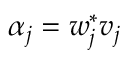Convert formula to latex. <formula><loc_0><loc_0><loc_500><loc_500>\alpha _ { j } = w _ { j } ^ { * } v _ { j }</formula> 